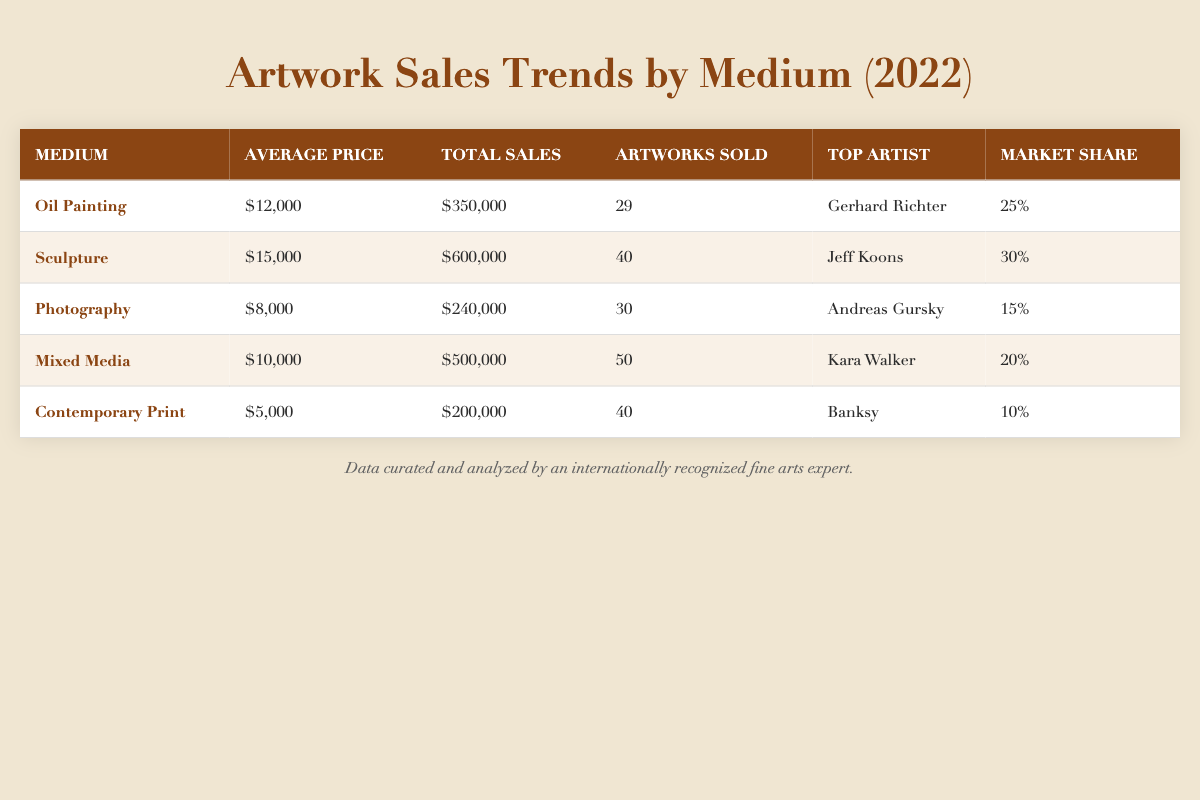What is the average price of Oil Painting? The average price is listed directly in the table under the "Average Price" column for Oil Painting, which is 12,000.
Answer: 12,000 Which medium had the highest total sales in 2022? By comparing the "Total Sales" column for each medium, Sculpture shows the highest total sales of 600,000.
Answer: Sculpture How many artworks were sold in total across all mediums? To find the total number of artworks sold, add the values from the "Artworks Sold" column: 29 (Oil Painting) + 40 (Sculpture) + 30 (Photography) + 50 (Mixed Media) + 40 (Contemporary Print) = 189.
Answer: 189 Is the market share percentage for Mixed Media greater than that of Photography? The market share percentage for Mixed Media is 20, while for Photography it is 15. Since 20 is greater than 15, the statement is true.
Answer: Yes What is the combined average price of Sculpture and Mixed Media? The average price for Sculpture is 15,000 and for Mixed Media is 10,000. Summing these gives: 15,000 + 10,000 = 25,000. To find the average price, divide by 2: 25,000 / 2 = 12,500.
Answer: 12,500 Which medium had the lowest average price and what was that price? Looking at the "Average Price" column, Contemporary Print has the lowest average price of 5,000.
Answer: 5,000 Are there more artworks sold in Oil Painting than in Photography? Oil Painting had 29 artworks sold and Photography had 30. Since 29 is less than 30, the statement is false.
Answer: No Who is the top artist for Sculpture and what is the market share percentage for this medium? According to the table, the top artist for Sculpture is Jeff Koons and the market share percentage is 30%.
Answer: Jeff Koons, 30% 